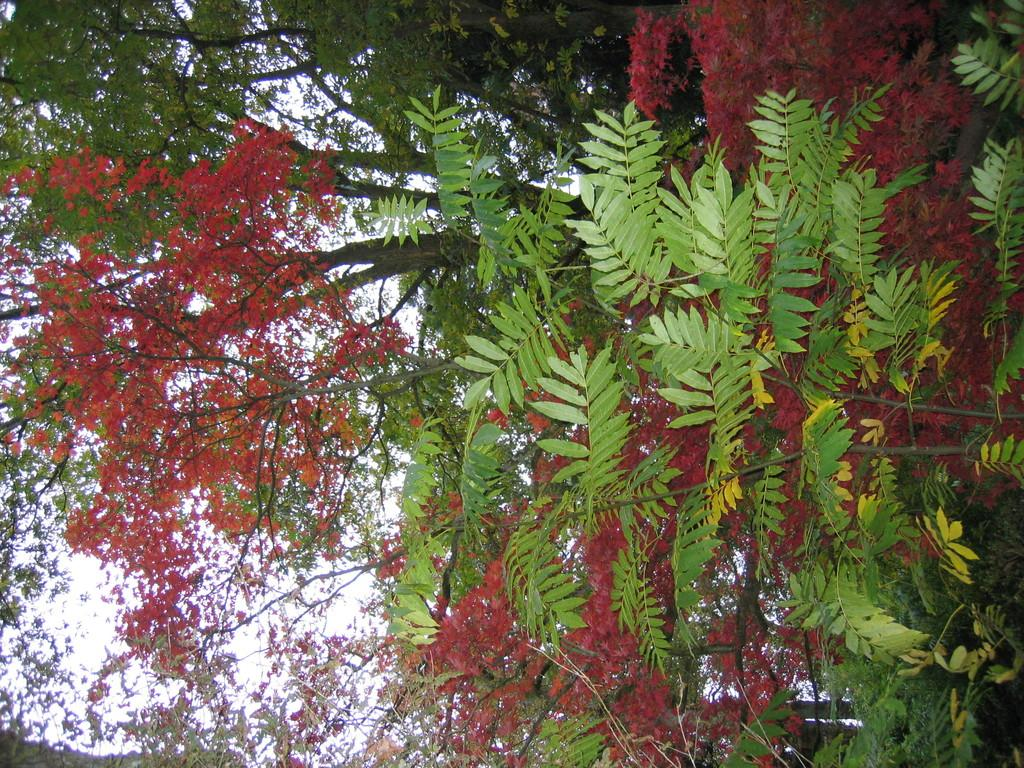What type of vegetation can be seen in the image? There are trees in the image. What is visible behind the trees in the image? The sky is visible behind the trees in the image. Can you touch the account in the image? There is no account present in the image, and therefore it cannot be touched. 